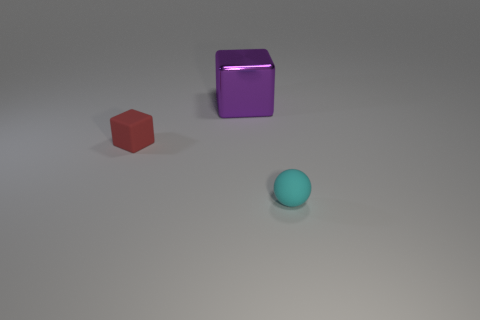Add 3 small green cubes. How many objects exist? 6 Subtract all cubes. How many objects are left? 1 Subtract 0 gray cylinders. How many objects are left? 3 Subtract all purple shiny blocks. Subtract all big blocks. How many objects are left? 1 Add 3 cyan objects. How many cyan objects are left? 4 Add 2 small rubber cubes. How many small rubber cubes exist? 3 